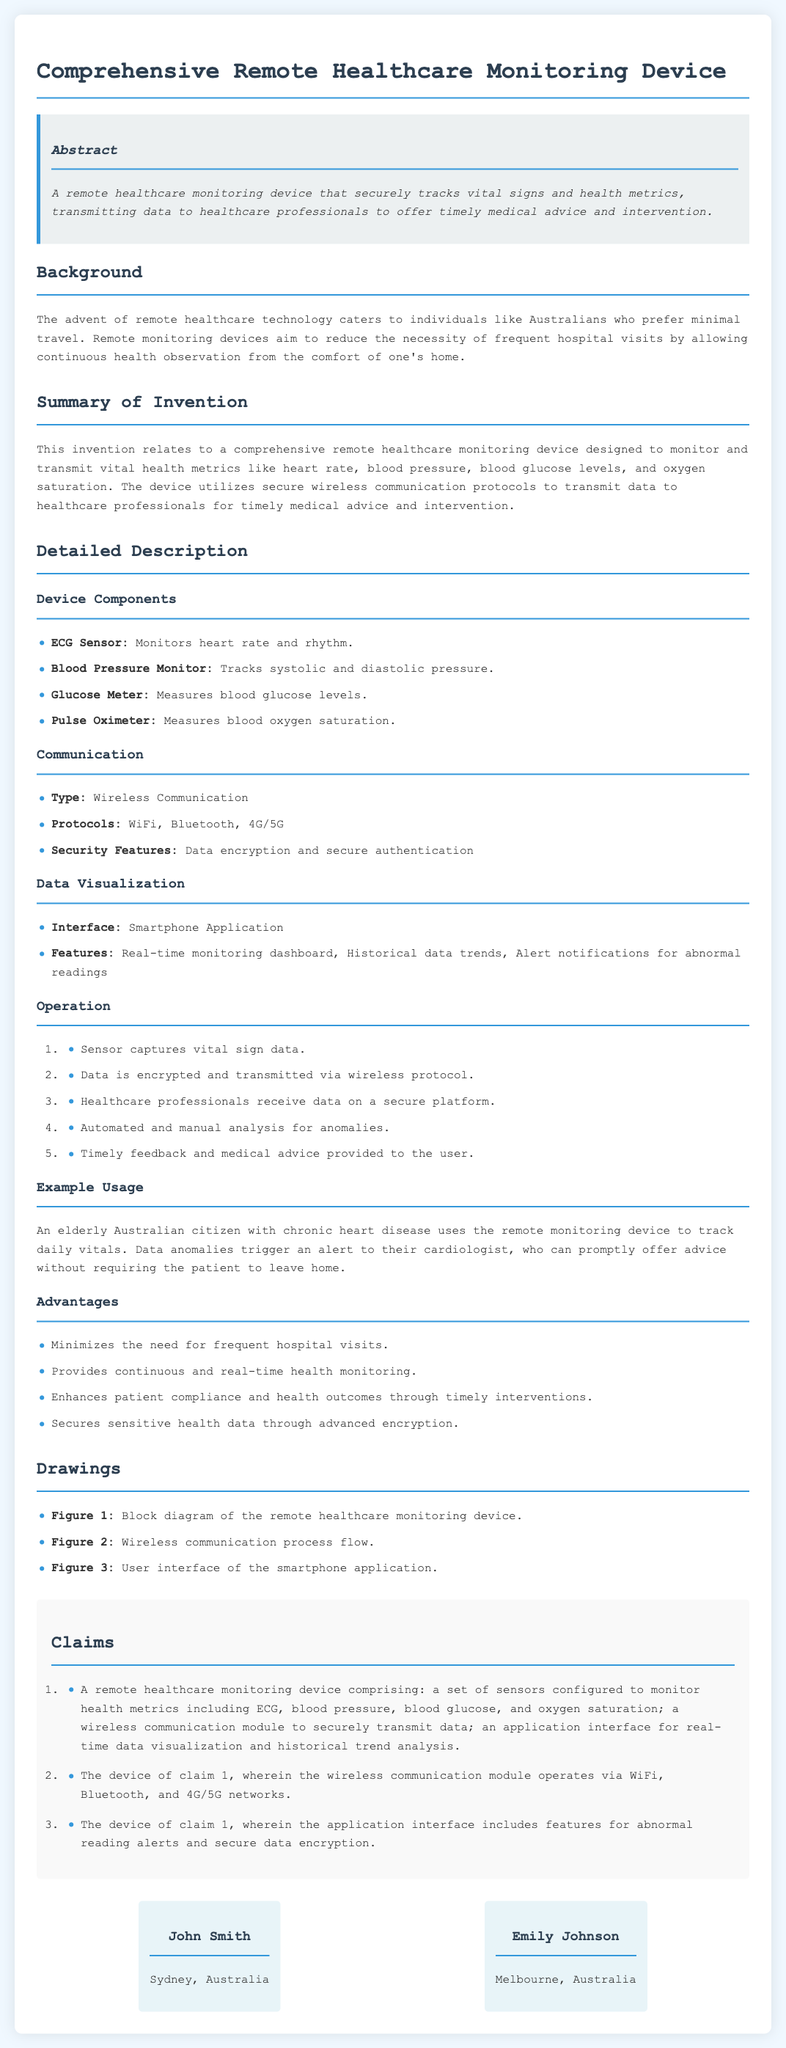What is the title of the patent application? The title is found at the top of the document and describes the subject of the application.
Answer: Comprehensive Remote Healthcare Monitoring Device What does the device monitor? The summary of the invention lists the specific health metrics the device tracks.
Answer: Vital health metrics Who are the inventors? The inventors are introduced in the document with their names and locations.
Answer: John Smith, Emily Johnson What communication protocols does the device use? The detailed description outlines the types of wireless communication protocols employed by the device.
Answer: WiFi, Bluetooth, 4G/5G What is the primary advantage of this device? The advantages section lists the benefits of using the healthcare monitoring device.
Answer: Minimizes the need for frequent hospital visits How is the data transmitted? The operation section describes how the data from the device is sent to healthcare professionals.
Answer: Wirelessly In what context is the device useful? The example usage illustrates a scenario where the device is beneficial for a user.
Answer: Tracking daily vitals of an elderly Australian citizen How many claims are listed in the patent? The claims section details the number of claims made regarding the device's features.
Answer: Three 